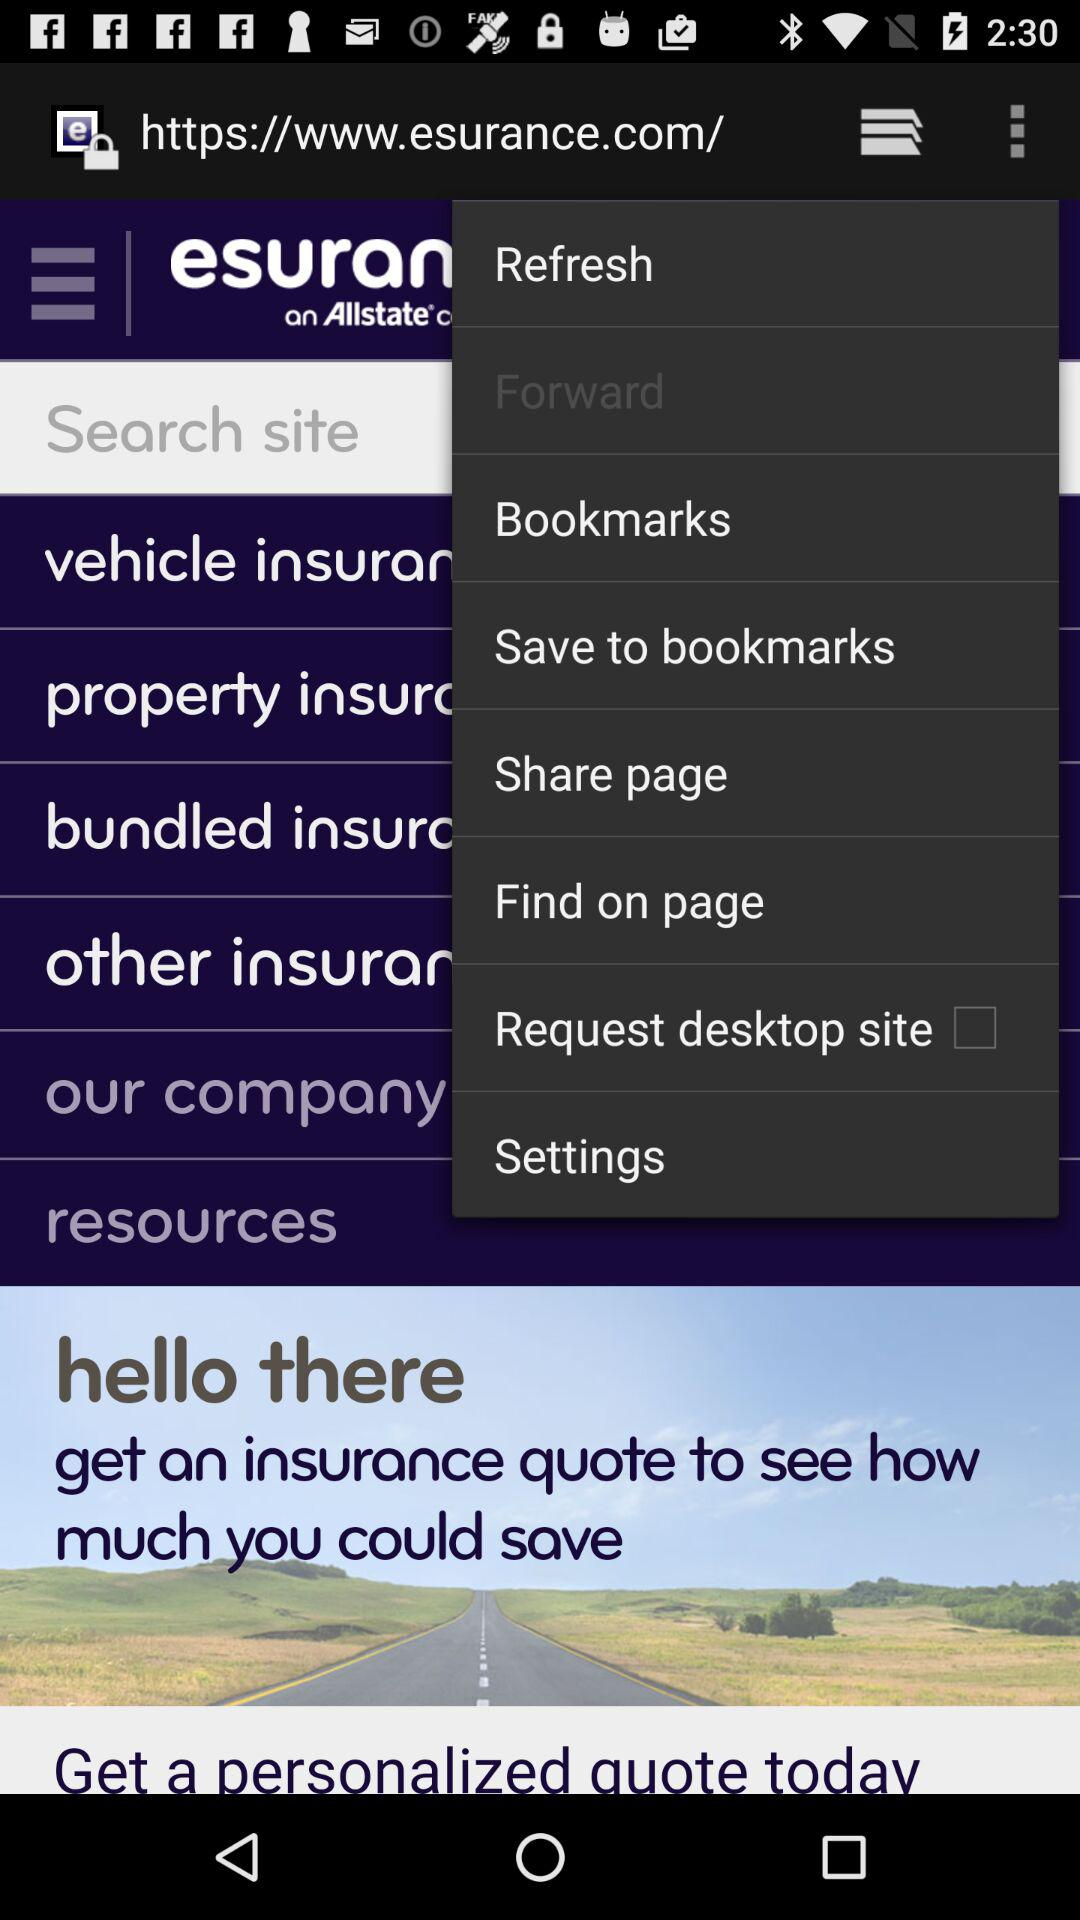What is the status of "Request desktop site"? The status is "off". 